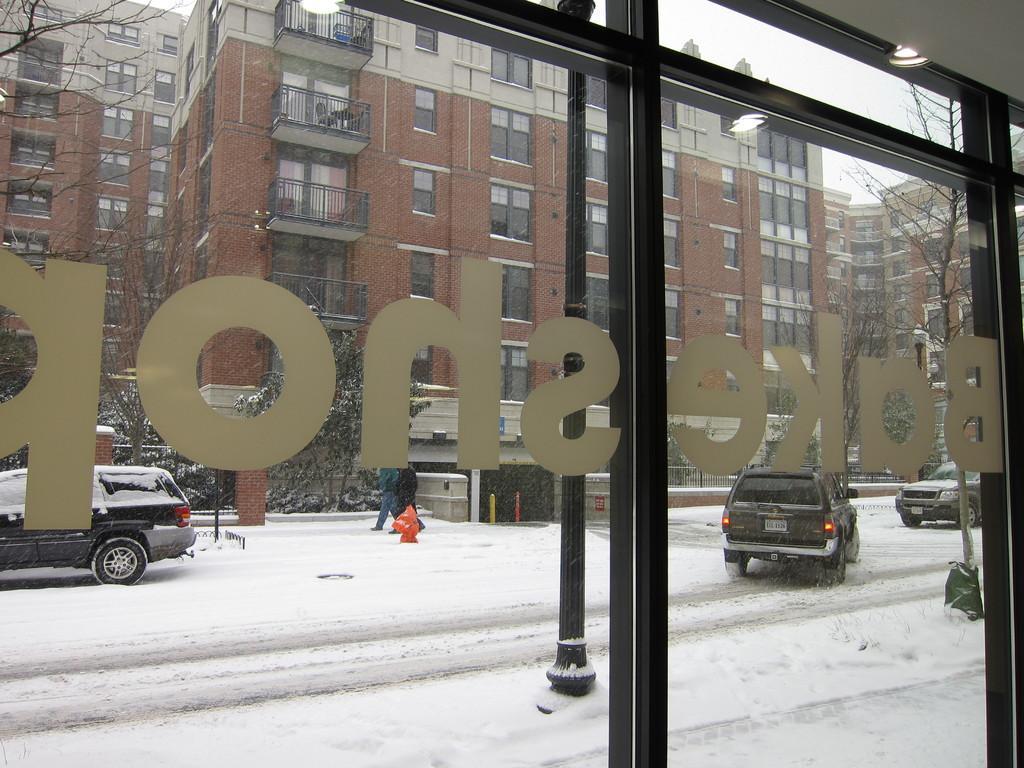In one or two sentences, can you explain what this image depicts? This image is taken indoors. In the middle of the image there is a glass door. Through the door we can see there are a few buildings with walls, windows, balconies, railings, doors and roofs. There are a few trees. There is a fence. A few cars are parked on the road and they are covered with snow. Two persons are walking in this snow. 